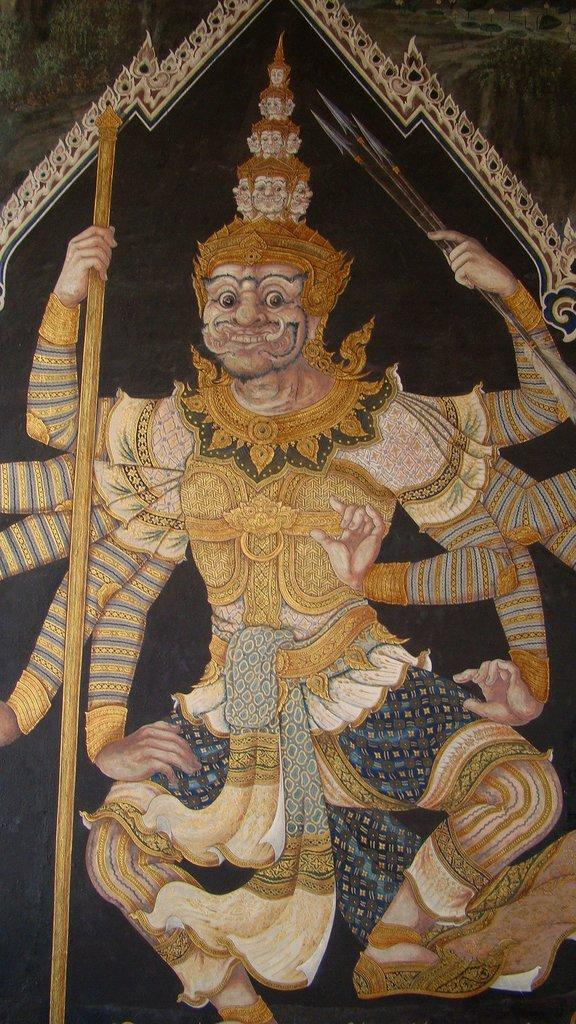What is the main subject of the image? There is a person depicted in the image. What is unique about the person's appearance? The person has many hands. What type of accessories is the person wearing? The person is wearing jewelry. What can be seen in the background of the image? There is a wall in the background of the image. On what material does the image appear to be printed or drawn? The image appears to be on a sheet or similar material. How many minutes does it take for the person to complete a task in the image? The image does not provide information about the person's actions or the time it takes to complete a task. What type of sticks are being used by the person in the image? There are no sticks visible in the image. 